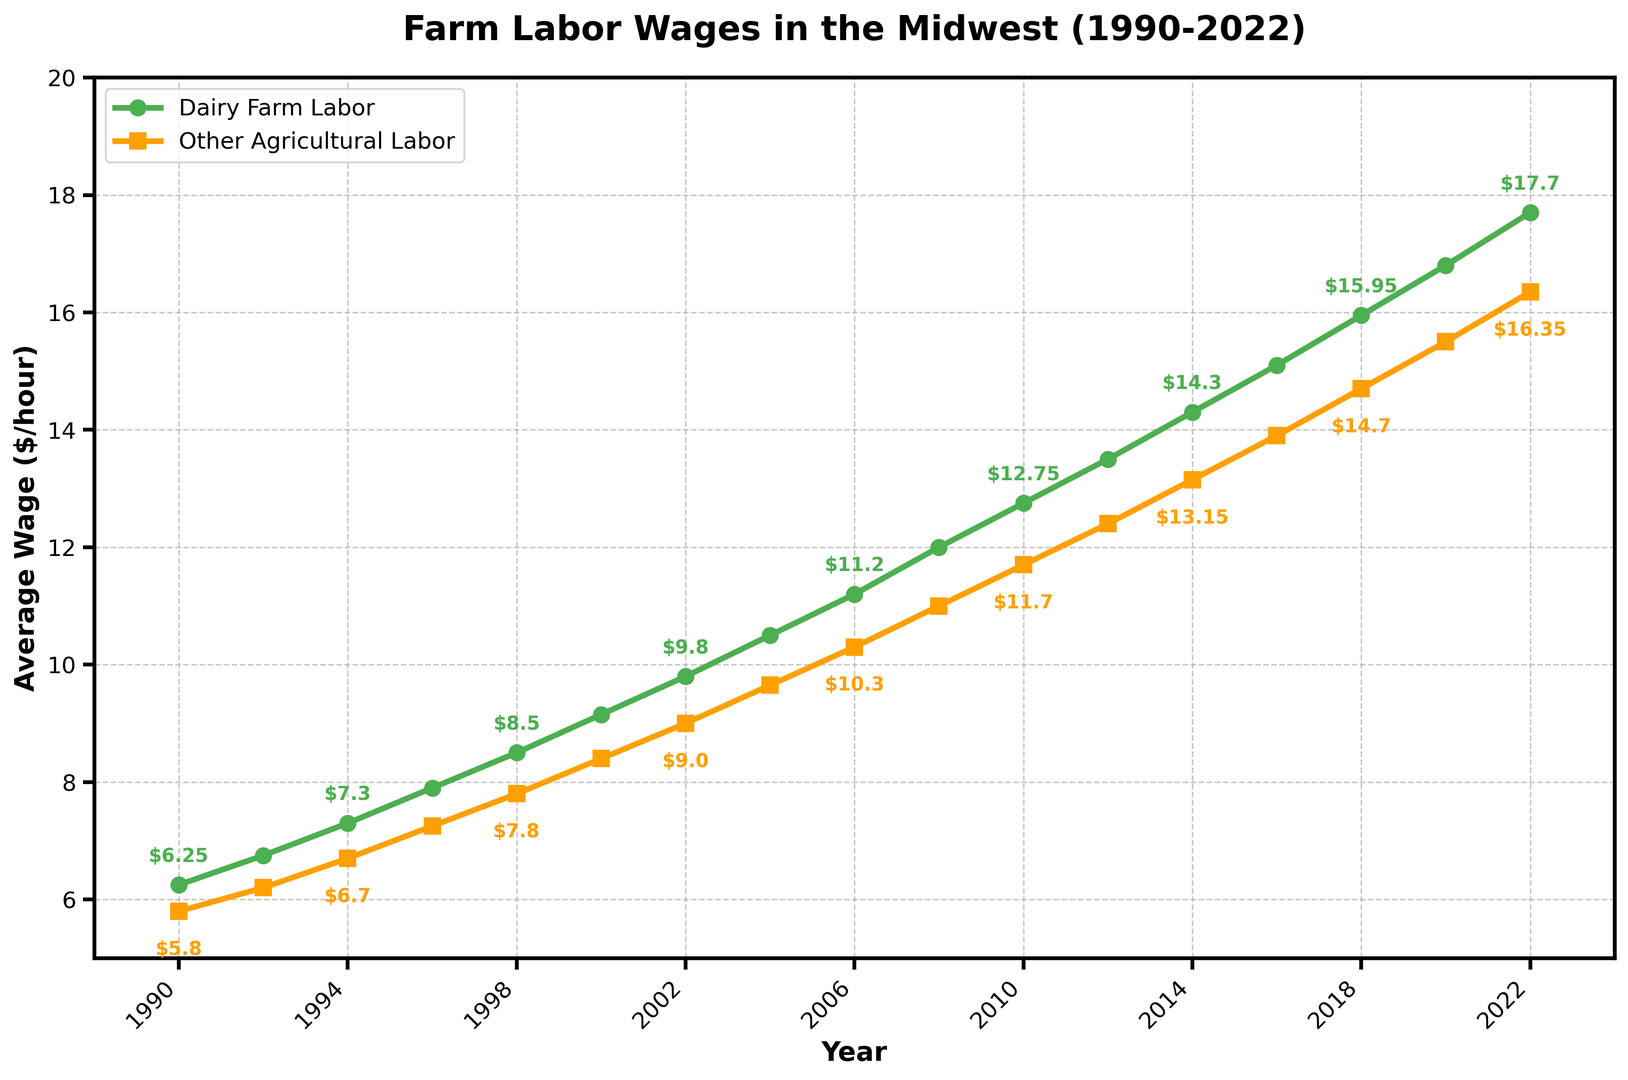What's the trend for dairy farm labor wages from 1990 to 2022? The trend for dairy farm labor wages shows a steady increase from $6.25 per hour in 1990 to $17.70 per hour in 2022. The wages increased consistently over the years without any significant drops.
Answer: Steady increase In which year did the other agricultural labor wage surpass $10 per hour? The other agricultural labor wage surpassed $10 per hour in the year 2006. By referring to the plotted data on the graph, the wage was exactly $10.30 per hour in 2006.
Answer: 2006 What is the wage difference between dairy farm labor and other agricultural labor in 2000? In 2000, the dairy farm labor wage was $9.15 per hour, and the other agricultural labor wage was $8.40 per hour. The difference between these wages is $9.15 - $8.40 = $0.75.
Answer: $0.75 Which sector had the higher average wage over the entire period? To find which sector had the higher average wage, we need to compute the average for both sectors over the given years. Dairy Farm Labor Wage averages to around $11.52 and Other Agricultural Labor Wage averages to around $10.71. Thus, dairy farm labor had the higher average wage.
Answer: Dairy Farm Labor How did the wage gap between dairy farm labor and other agricultural labor change from 1990 to 2022? In 1990, the wage gap was $6.25 - $5.80 = $0.45. In 2022, the wage gap was $17.70 - $16.35 = $1.35. The wage gap increased from $0.45 to $1.35 over the period.
Answer: Increased During which time periods did the difference between the dairy farm labor wage and the other agricultural labor wage remain relatively constant? The wage difference remained relatively constant between 1990-1998 and 2004-2012. During these periods, the difference did not vary significantly and remained around a consistent value.
Answer: 1990-1998 and 2004-2012 What visual element distinguishes the dairy farm labor wage line from the other agricultural labor wage line? The dairy farm labor wage line is marked with circles ('o'), while the other agricultural labor wage line is marked with squares ('s'). The color of the dairy farm labor wage line is green, whereas the other agricultural labor wage line is yellow.
Answer: Shape and color By how much did the dairy farm labor wage increase from 2014 to 2022? The dairy farm labor wage in 2014 was $14.30 per hour. By 2022, it had increased to $17.70 per hour. The increase can be calculated as $17.70 - $14.30 = $3.40.
Answer: $3.40 What is the visual trend for other agricultural labor wages from 2002 to 2014? The visual trend shows a steady upward trajectory for other agricultural labor wages, increasing from $9.00 per hour in 2002 to $13.15 per hour in 2014.
Answer: Steady increase Which year had the smallest wage gap between dairy farm labor and other agricultural labor? The smallest wage gap occurred in 2002, where dairy farm labor wage was $9.80 per hour and other agricultural labor wage was $9.00 per hour. The gap is $9.80 - $9.00 = $0.80.
Answer: 2002 